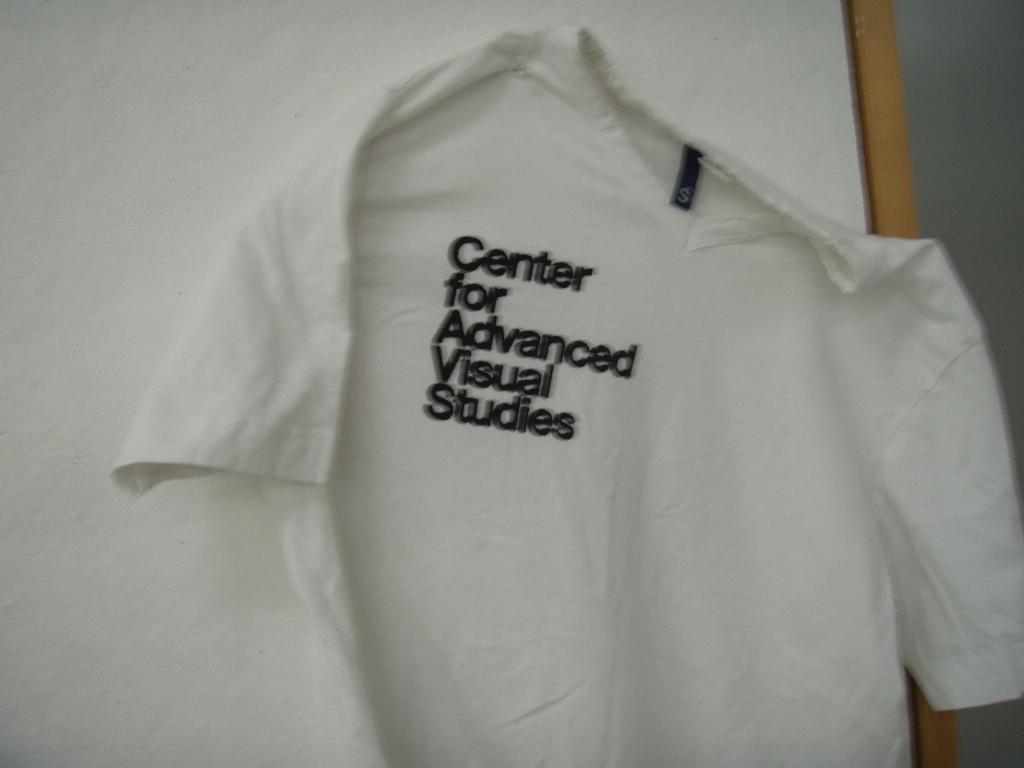What do they do in that company?
Keep it short and to the point. Visual studies. 